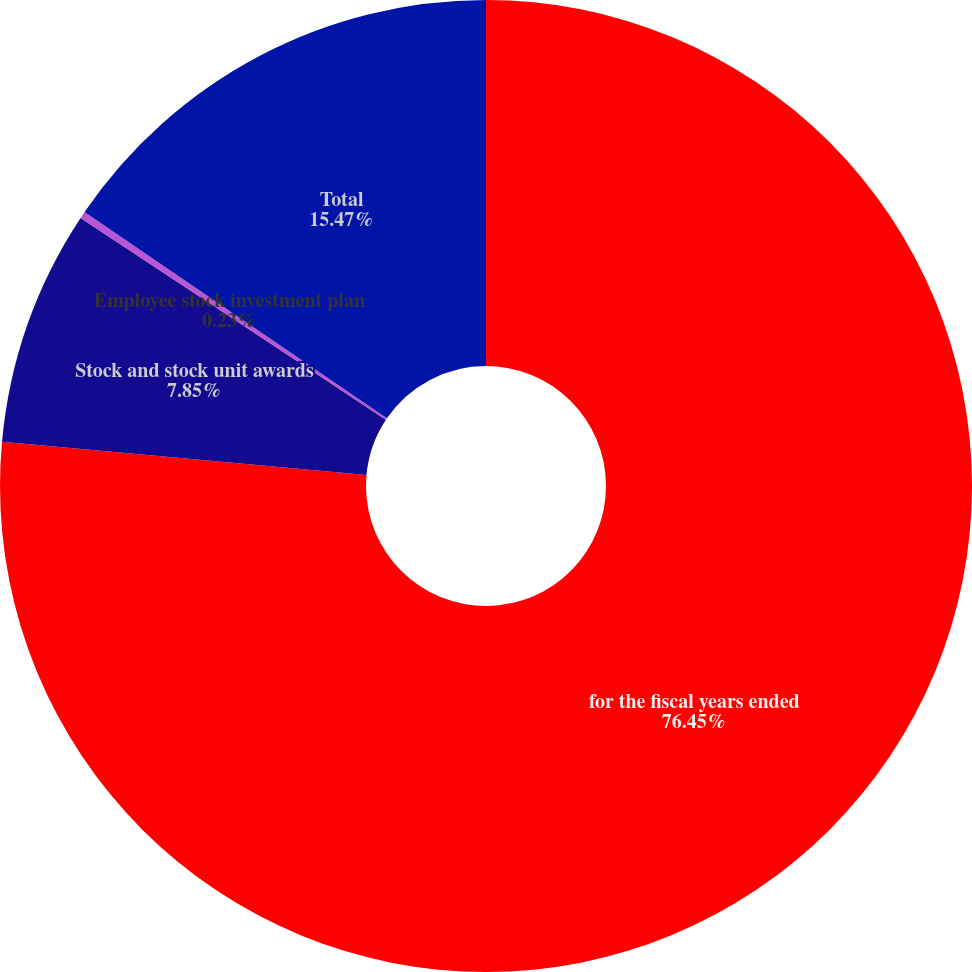Convert chart to OTSL. <chart><loc_0><loc_0><loc_500><loc_500><pie_chart><fcel>for the fiscal years ended<fcel>Stock and stock unit awards<fcel>Employee stock investment plan<fcel>Total<nl><fcel>76.44%<fcel>7.85%<fcel>0.23%<fcel>15.47%<nl></chart> 